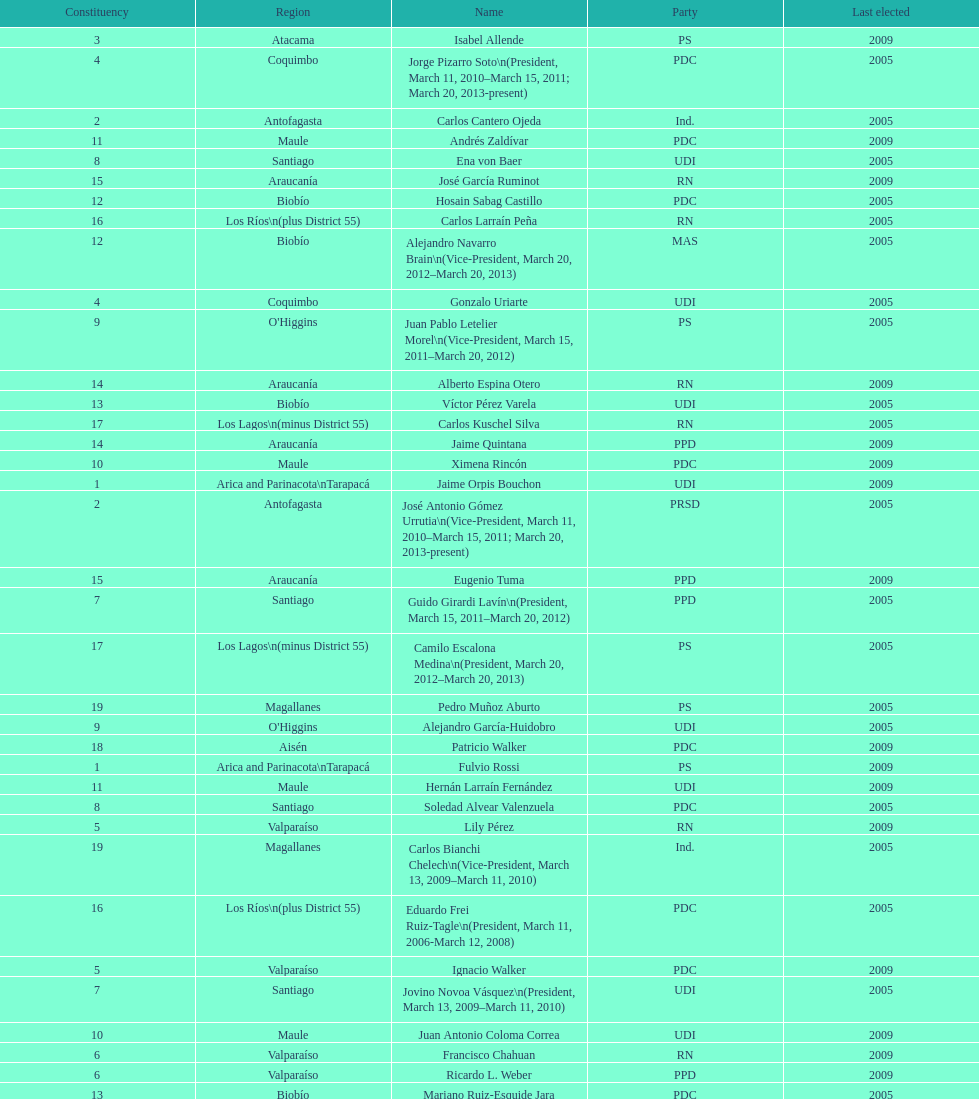Could you help me parse every detail presented in this table? {'header': ['Constituency', 'Region', 'Name', 'Party', 'Last elected'], 'rows': [['3', 'Atacama', 'Isabel Allende', 'PS', '2009'], ['4', 'Coquimbo', 'Jorge Pizarro Soto\\n(President, March 11, 2010–March 15, 2011; March 20, 2013-present)', 'PDC', '2005'], ['2', 'Antofagasta', 'Carlos Cantero Ojeda', 'Ind.', '2005'], ['11', 'Maule', 'Andrés Zaldívar', 'PDC', '2009'], ['8', 'Santiago', 'Ena von Baer', 'UDI', '2005'], ['15', 'Araucanía', 'José García Ruminot', 'RN', '2009'], ['12', 'Biobío', 'Hosain Sabag Castillo', 'PDC', '2005'], ['16', 'Los Ríos\\n(plus District 55)', 'Carlos Larraín Peña', 'RN', '2005'], ['12', 'Biobío', 'Alejandro Navarro Brain\\n(Vice-President, March 20, 2012–March 20, 2013)', 'MAS', '2005'], ['4', 'Coquimbo', 'Gonzalo Uriarte', 'UDI', '2005'], ['9', "O'Higgins", 'Juan Pablo Letelier Morel\\n(Vice-President, March 15, 2011–March 20, 2012)', 'PS', '2005'], ['14', 'Araucanía', 'Alberto Espina Otero', 'RN', '2009'], ['13', 'Biobío', 'Víctor Pérez Varela', 'UDI', '2005'], ['17', 'Los Lagos\\n(minus District 55)', 'Carlos Kuschel Silva', 'RN', '2005'], ['14', 'Araucanía', 'Jaime Quintana', 'PPD', '2009'], ['10', 'Maule', 'Ximena Rincón', 'PDC', '2009'], ['1', 'Arica and Parinacota\\nTarapacá', 'Jaime Orpis Bouchon', 'UDI', '2009'], ['2', 'Antofagasta', 'José Antonio Gómez Urrutia\\n(Vice-President, March 11, 2010–March 15, 2011; March 20, 2013-present)', 'PRSD', '2005'], ['15', 'Araucanía', 'Eugenio Tuma', 'PPD', '2009'], ['7', 'Santiago', 'Guido Girardi Lavín\\n(President, March 15, 2011–March 20, 2012)', 'PPD', '2005'], ['17', 'Los Lagos\\n(minus District 55)', 'Camilo Escalona Medina\\n(President, March 20, 2012–March 20, 2013)', 'PS', '2005'], ['19', 'Magallanes', 'Pedro Muñoz Aburto', 'PS', '2005'], ['9', "O'Higgins", 'Alejandro García-Huidobro', 'UDI', '2005'], ['18', 'Aisén', 'Patricio Walker', 'PDC', '2009'], ['1', 'Arica and Parinacota\\nTarapacá', 'Fulvio Rossi', 'PS', '2009'], ['11', 'Maule', 'Hernán Larraín Fernández', 'UDI', '2009'], ['8', 'Santiago', 'Soledad Alvear Valenzuela', 'PDC', '2005'], ['5', 'Valparaíso', 'Lily Pérez', 'RN', '2009'], ['19', 'Magallanes', 'Carlos Bianchi Chelech\\n(Vice-President, March 13, 2009–March 11, 2010)', 'Ind.', '2005'], ['16', 'Los Ríos\\n(plus District 55)', 'Eduardo Frei Ruiz-Tagle\\n(President, March 11, 2006-March 12, 2008)', 'PDC', '2005'], ['5', 'Valparaíso', 'Ignacio Walker', 'PDC', '2009'], ['7', 'Santiago', 'Jovino Novoa Vásquez\\n(President, March 13, 2009–March 11, 2010)', 'UDI', '2005'], ['10', 'Maule', 'Juan Antonio Coloma Correa', 'UDI', '2009'], ['6', 'Valparaíso', 'Francisco Chahuan', 'RN', '2009'], ['6', 'Valparaíso', 'Ricardo L. Weber', 'PPD', '2009'], ['13', 'Biobío', 'Mariano Ruiz-Esquide Jara', 'PDC', '2005'], ['18', 'Aisén', 'Antonio Horvath Kiss', 'RN', '2001'], ['3', 'Atacama', 'Baldo Prokurica Prokurica\\n(Vice-President, March 12, 2008-March 13, 2009)', 'RN', '2009']]} How long was baldo prokurica prokurica vice-president? 1 year. 